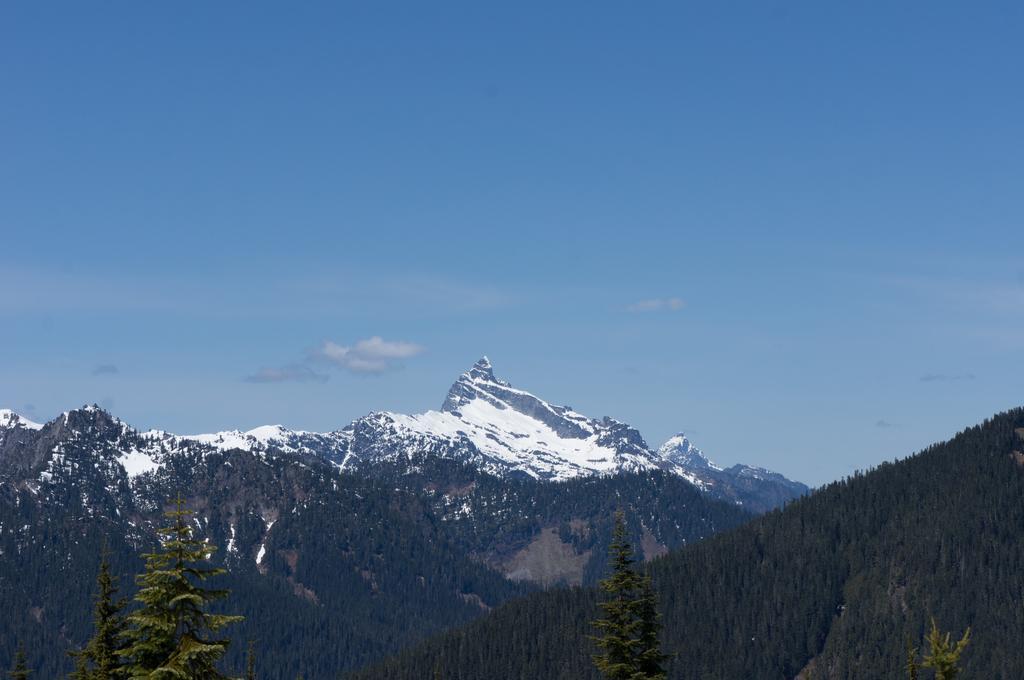Can you describe this image briefly? At the bottom of the picture, we see the trees. There are trees and mountains in the background. These mountains are covered with the snow. At the top, we see the clouds and the sky, which is blue in color. 